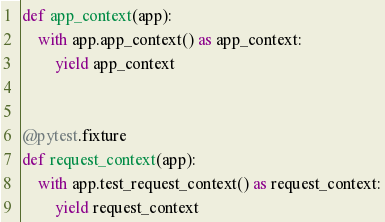<code> <loc_0><loc_0><loc_500><loc_500><_Python_>def app_context(app):
    with app.app_context() as app_context:
        yield app_context


@pytest.fixture
def request_context(app):
    with app.test_request_context() as request_context:
        yield request_context
</code> 